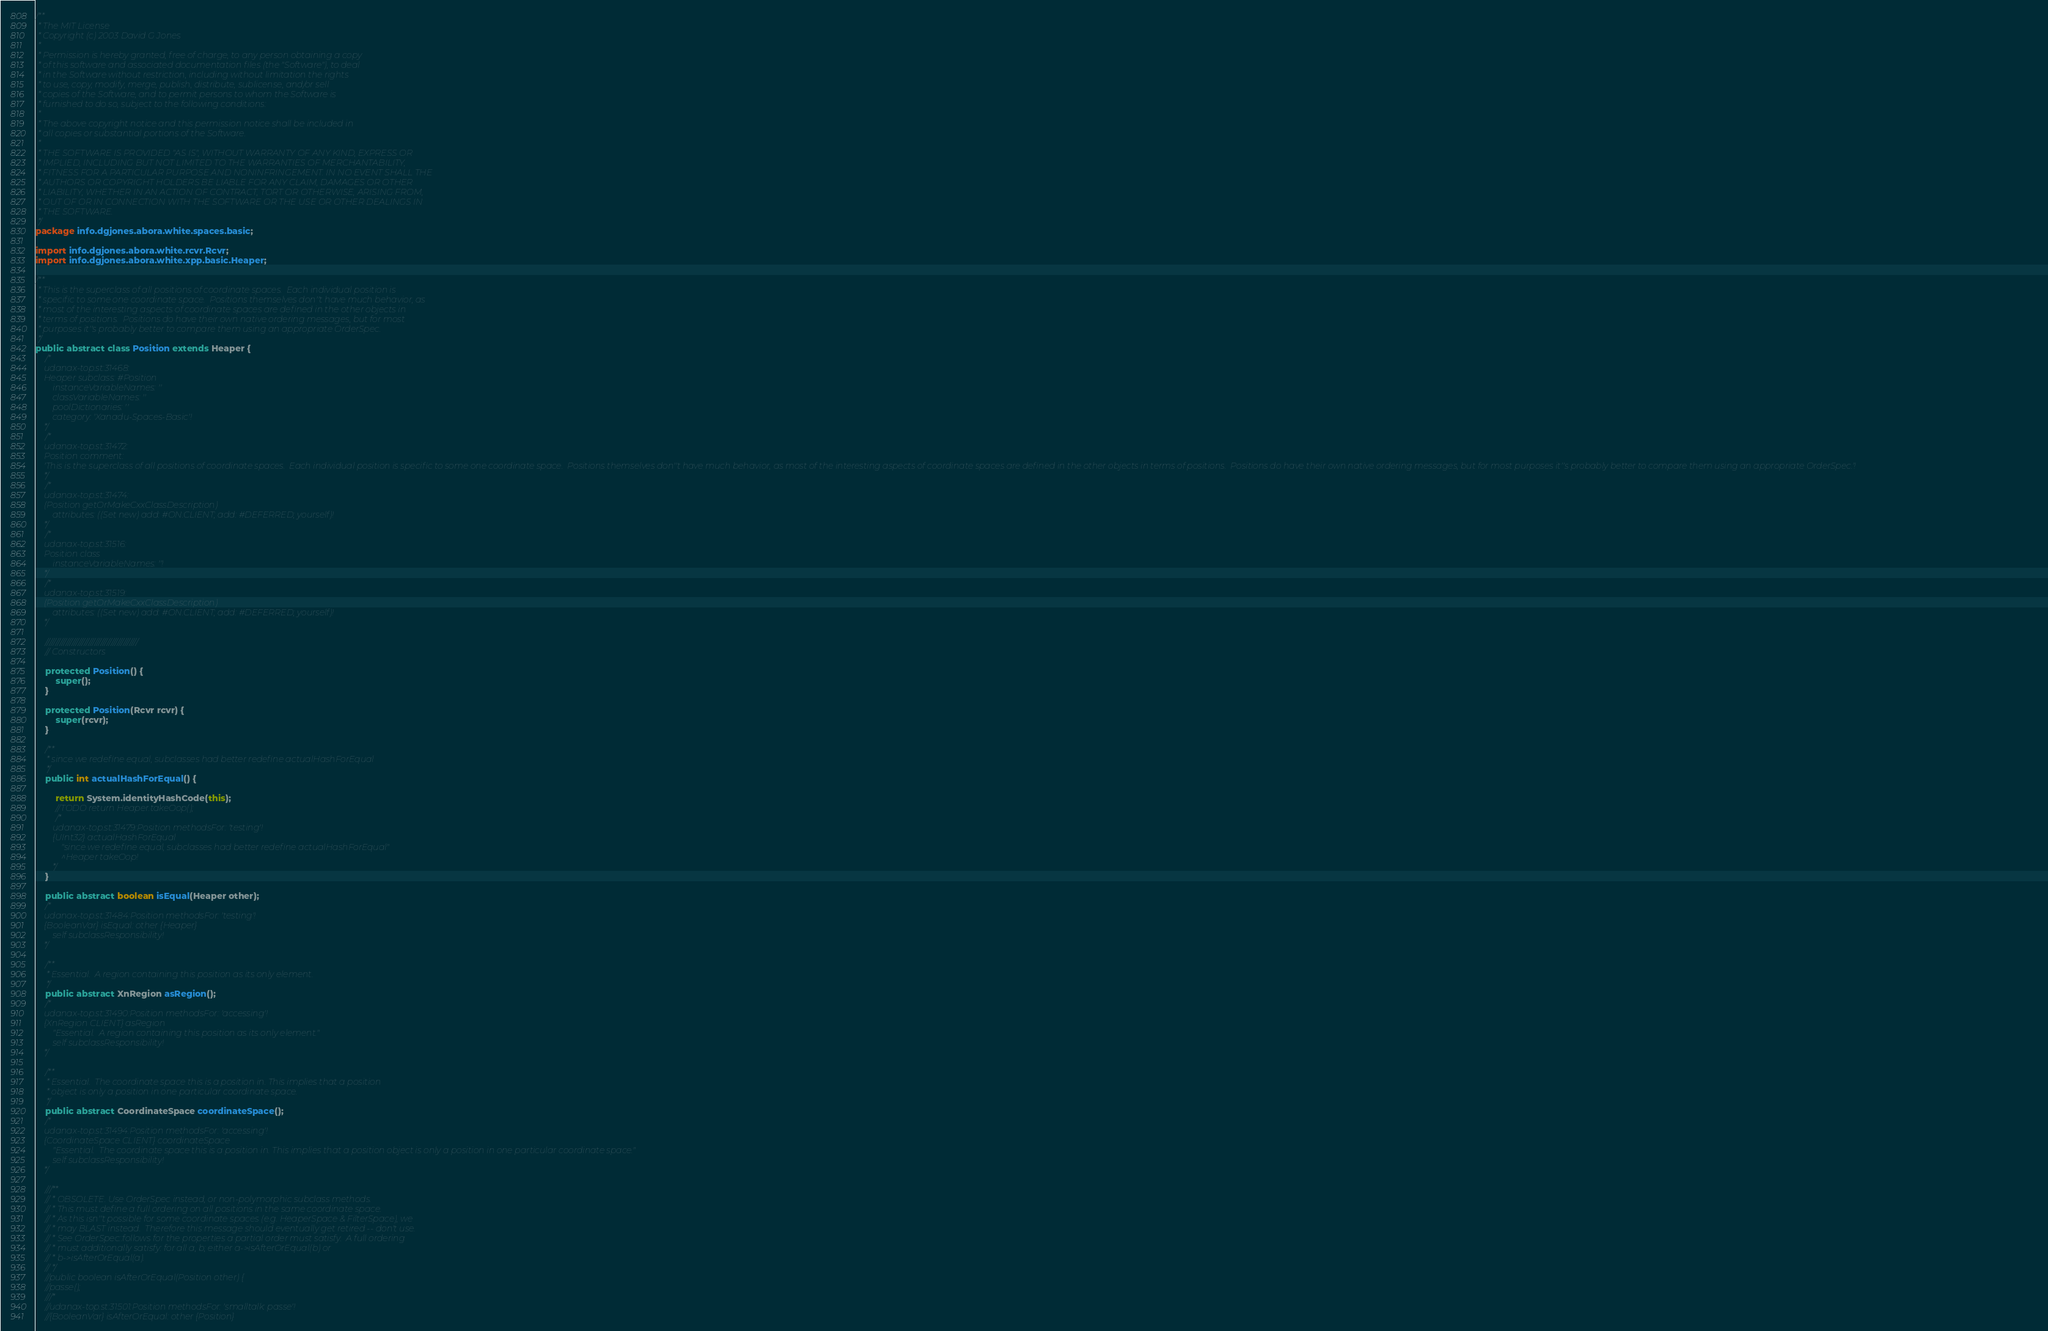<code> <loc_0><loc_0><loc_500><loc_500><_Java_>/**
 * The MIT License
 * Copyright (c) 2003 David G Jones
 *
 * Permission is hereby granted, free of charge, to any person obtaining a copy
 * of this software and associated documentation files (the "Software"), to deal
 * in the Software without restriction, including without limitation the rights
 * to use, copy, modify, merge, publish, distribute, sublicense, and/or sell
 * copies of the Software, and to permit persons to whom the Software is
 * furnished to do so, subject to the following conditions:
 *
 * The above copyright notice and this permission notice shall be included in
 * all copies or substantial portions of the Software.
 *
 * THE SOFTWARE IS PROVIDED "AS IS", WITHOUT WARRANTY OF ANY KIND, EXPRESS OR
 * IMPLIED, INCLUDING BUT NOT LIMITED TO THE WARRANTIES OF MERCHANTABILITY,
 * FITNESS FOR A PARTICULAR PURPOSE AND NONINFRINGEMENT. IN NO EVENT SHALL THE
 * AUTHORS OR COPYRIGHT HOLDERS BE LIABLE FOR ANY CLAIM, DAMAGES OR OTHER
 * LIABILITY, WHETHER IN AN ACTION OF CONTRACT, TORT OR OTHERWISE, ARISING FROM,
 * OUT OF OR IN CONNECTION WITH THE SOFTWARE OR THE USE OR OTHER DEALINGS IN
 * THE SOFTWARE.
 */
package info.dgjones.abora.white.spaces.basic;

import info.dgjones.abora.white.rcvr.Rcvr;
import info.dgjones.abora.white.xpp.basic.Heaper;

/**
 * This is the superclass of all positions of coordinate spaces.  Each individual position is
 * specific to some one coordinate space.  Positions themselves don''t have much behavior, as
 * most of the interesting aspects of coordinate spaces are defined in the other objects in
 * terms of positions.  Positions do have their own native ordering messages, but for most
 * purposes it''s probably better to compare them using an appropriate OrderSpec.
 */
public abstract class Position extends Heaper {
	/*
	udanax-top.st:31468:
	Heaper subclass: #Position
		instanceVariableNames: ''
		classVariableNames: ''
		poolDictionaries: ''
		category: 'Xanadu-Spaces-Basic'!
	*/
	/*
	udanax-top.st:31472:
	Position comment:
	'This is the superclass of all positions of coordinate spaces.  Each individual position is specific to some one coordinate space.  Positions themselves don''t have much behavior, as most of the interesting aspects of coordinate spaces are defined in the other objects in terms of positions.  Positions do have their own native ordering messages, but for most purposes it''s probably better to compare them using an appropriate OrderSpec.'!
	*/
	/*
	udanax-top.st:31474:
	(Position getOrMakeCxxClassDescription)
		attributes: ((Set new) add: #ON.CLIENT; add: #DEFERRED; yourself)!
	*/
	/*
	udanax-top.st:31516:
	Position class
		instanceVariableNames: ''!
	*/
	/*
	udanax-top.st:31519:
	(Position getOrMakeCxxClassDescription)
		attributes: ((Set new) add: #ON.CLIENT; add: #DEFERRED; yourself)!
	*/

	/////////////////////////////////////////////
	// Constructors

	protected Position() {
		super();
	}

	protected Position(Rcvr rcvr) {
		super(rcvr);
	}

	/**
	 * since we redefine equal, subclasses had better redefine actualHashForEqual
	 */
	public int actualHashForEqual() {

		return System.identityHashCode(this);
		//TODO return Heaper.takeOop();
		/*
		udanax-top.st:31479:Position methodsFor: 'testing'!
		{UInt32} actualHashForEqual
			"since we redefine equal, subclasses had better redefine actualHashForEqual"
			^Heaper takeOop!
		*/
	}

	public abstract boolean isEqual(Heaper other);
	/*
	udanax-top.st:31484:Position methodsFor: 'testing'!
	{BooleanVar} isEqual: other {Heaper} 
		self subclassResponsibility!
	*/

	/**
	 * Essential.  A region containing this position as its only element.
	 */
	public abstract XnRegion asRegion();
	/*
	udanax-top.st:31490:Position methodsFor: 'accessing'!
	{XnRegion CLIENT} asRegion
		"Essential.  A region containing this position as its only element."
		self subclassResponsibility!
	*/

	/**
	 * Essential.  The coordinate space this is a position in. This implies that a position
	 * object is only a position in one particular coordinate space.
	 */
	public abstract CoordinateSpace coordinateSpace();
	/*
	udanax-top.st:31494:Position methodsFor: 'accessing'!
	{CoordinateSpace CLIENT} coordinateSpace
		"Essential.  The coordinate space this is a position in. This implies that a position object is only a position in one particular coordinate space."
		self subclassResponsibility!
	*/

	///**
	// * OBSOLETE. Use OrderSpec instead, or non-polymorphic subclass methods.
	// * This must define a full ordering on all positions in the same coordinate space.
	// * As this isn''t possible for some coordinate spaces (e.g. HeaperSpace & FilterSpace), we
	// * may BLAST instead.  Therefore this message should eventually get retired -- don't use.
	// * See OrderSpec::follows for the properties a partial order must satisfy.  A full ordering
	// * must additionally satisfy: for all a, b; either a->isAfterOrEqual(b) or
	// * b->isAfterOrEqual(a).
	// */
	//public boolean isAfterOrEqual(Position other) {
	//passe();
	///*
	//udanax-top.st:31501:Position methodsFor: 'smalltalk: passe'!
	//{BooleanVar} isAfterOrEqual: other {Position}</code> 